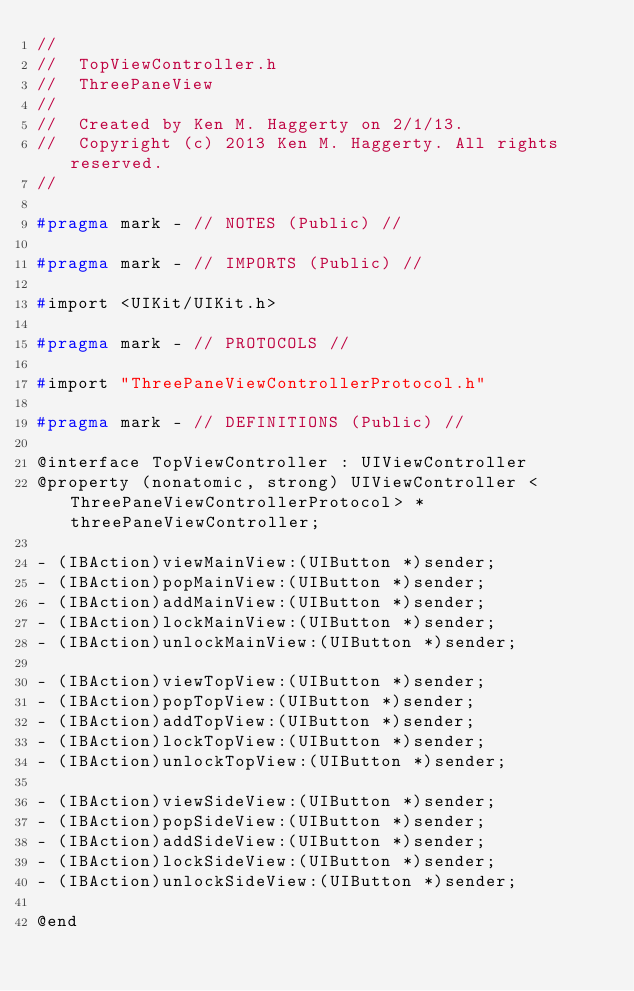<code> <loc_0><loc_0><loc_500><loc_500><_C_>//
//  TopViewController.h
//  ThreePaneView
//
//  Created by Ken M. Haggerty on 2/1/13.
//  Copyright (c) 2013 Ken M. Haggerty. All rights reserved.
//

#pragma mark - // NOTES (Public) //

#pragma mark - // IMPORTS (Public) //

#import <UIKit/UIKit.h>

#pragma mark - // PROTOCOLS //

#import "ThreePaneViewControllerProtocol.h"

#pragma mark - // DEFINITIONS (Public) //

@interface TopViewController : UIViewController
@property (nonatomic, strong) UIViewController <ThreePaneViewControllerProtocol> *threePaneViewController;

- (IBAction)viewMainView:(UIButton *)sender;
- (IBAction)popMainView:(UIButton *)sender;
- (IBAction)addMainView:(UIButton *)sender;
- (IBAction)lockMainView:(UIButton *)sender;
- (IBAction)unlockMainView:(UIButton *)sender;

- (IBAction)viewTopView:(UIButton *)sender;
- (IBAction)popTopView:(UIButton *)sender;
- (IBAction)addTopView:(UIButton *)sender;
- (IBAction)lockTopView:(UIButton *)sender;
- (IBAction)unlockTopView:(UIButton *)sender;

- (IBAction)viewSideView:(UIButton *)sender;
- (IBAction)popSideView:(UIButton *)sender;
- (IBAction)addSideView:(UIButton *)sender;
- (IBAction)lockSideView:(UIButton *)sender;
- (IBAction)unlockSideView:(UIButton *)sender;

@end</code> 